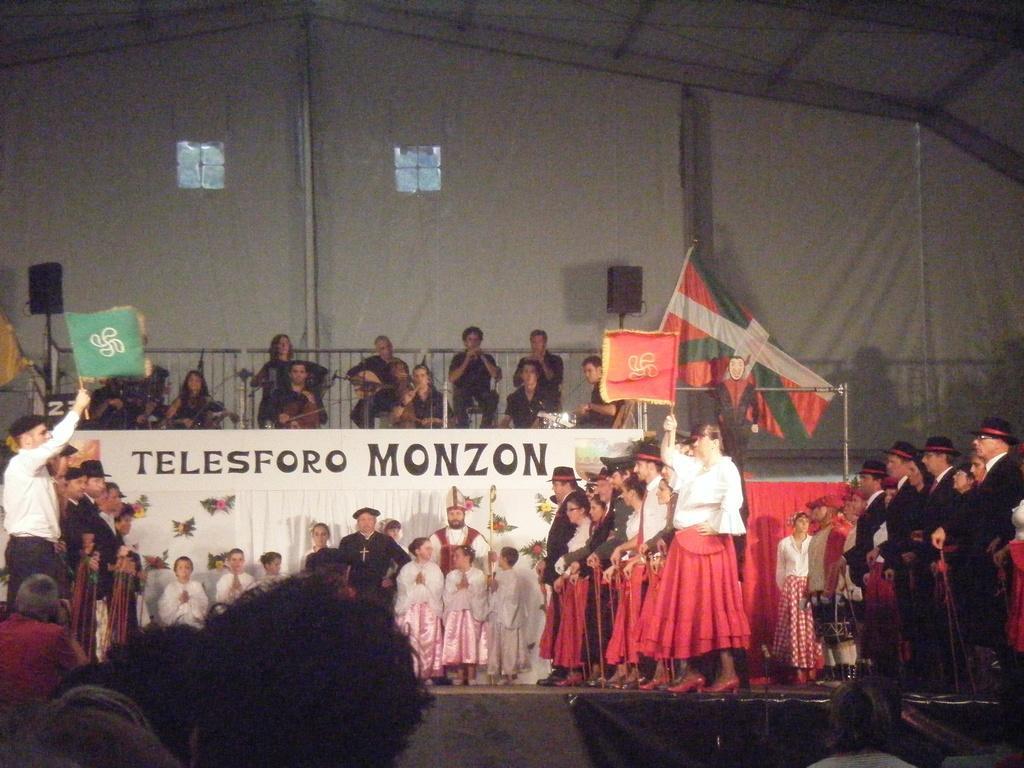Can you describe this image briefly? In this picture we can see a group of people,some people are holding flags and in the background we can see a banner,speakers,poles. 